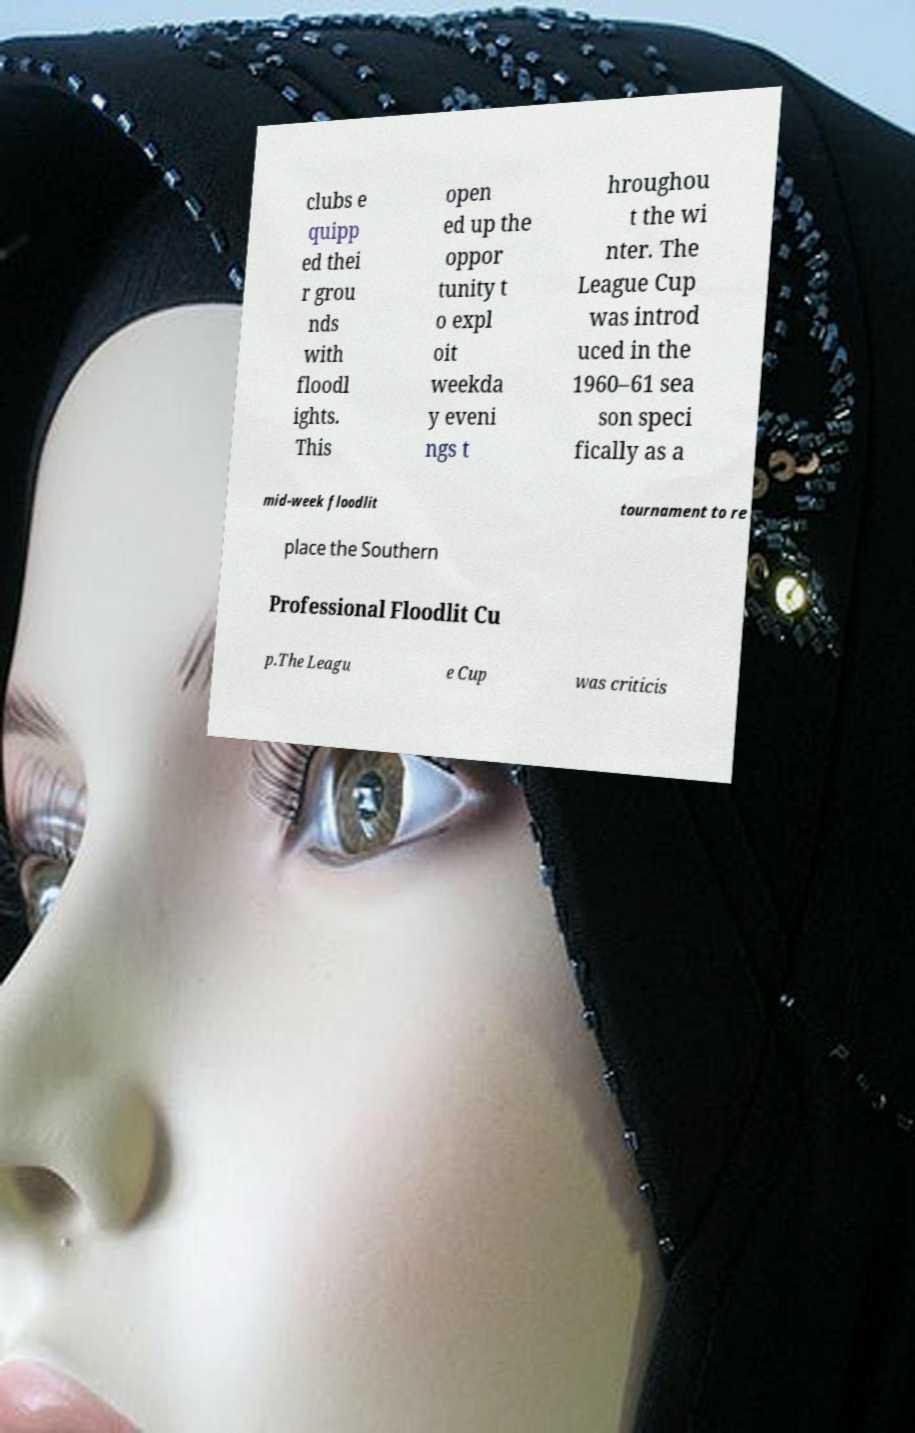Can you read and provide the text displayed in the image?This photo seems to have some interesting text. Can you extract and type it out for me? clubs e quipp ed thei r grou nds with floodl ights. This open ed up the oppor tunity t o expl oit weekda y eveni ngs t hroughou t the wi nter. The League Cup was introd uced in the 1960–61 sea son speci fically as a mid-week floodlit tournament to re place the Southern Professional Floodlit Cu p.The Leagu e Cup was criticis 